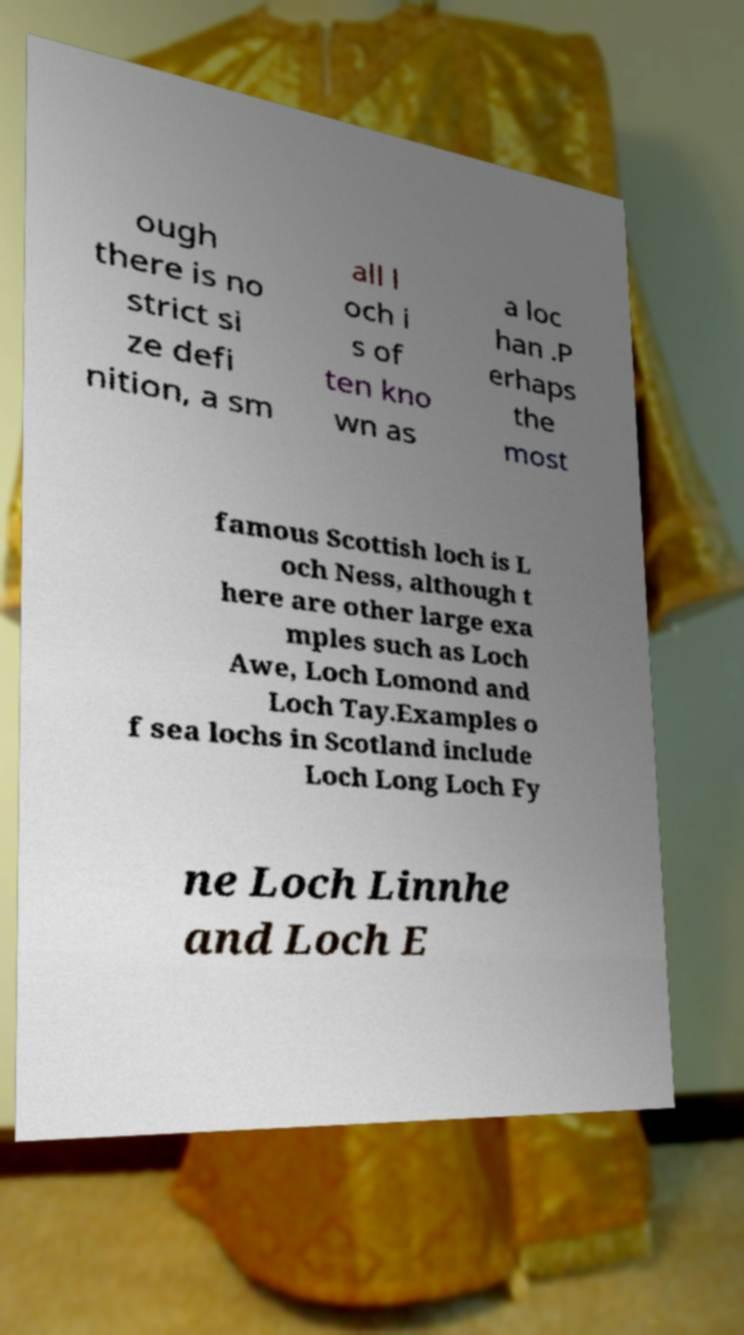Can you read and provide the text displayed in the image?This photo seems to have some interesting text. Can you extract and type it out for me? ough there is no strict si ze defi nition, a sm all l och i s of ten kno wn as a loc han .P erhaps the most famous Scottish loch is L och Ness, although t here are other large exa mples such as Loch Awe, Loch Lomond and Loch Tay.Examples o f sea lochs in Scotland include Loch Long Loch Fy ne Loch Linnhe and Loch E 